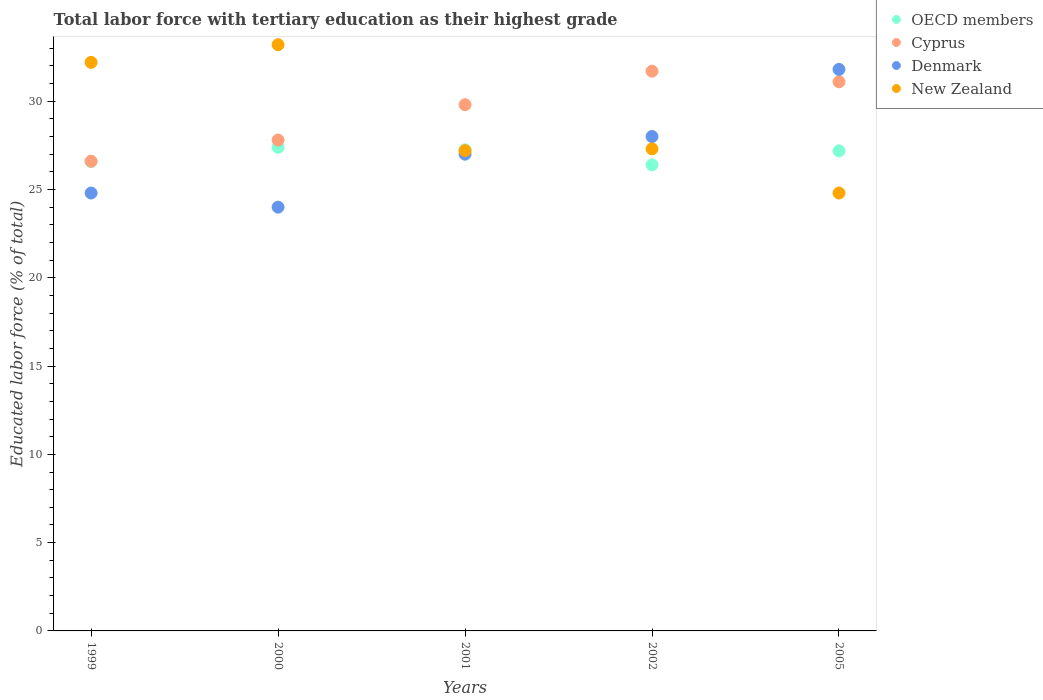How many different coloured dotlines are there?
Make the answer very short. 4. Is the number of dotlines equal to the number of legend labels?
Make the answer very short. Yes. What is the percentage of male labor force with tertiary education in Cyprus in 2005?
Provide a short and direct response. 31.1. Across all years, what is the maximum percentage of male labor force with tertiary education in Denmark?
Provide a succinct answer. 31.8. Across all years, what is the minimum percentage of male labor force with tertiary education in OECD members?
Offer a terse response. 26.4. In which year was the percentage of male labor force with tertiary education in Denmark minimum?
Your answer should be very brief. 2000. What is the total percentage of male labor force with tertiary education in Cyprus in the graph?
Offer a very short reply. 147. What is the difference between the percentage of male labor force with tertiary education in Denmark in 1999 and that in 2002?
Offer a terse response. -3.2. What is the average percentage of male labor force with tertiary education in OECD members per year?
Ensure brevity in your answer.  26.96. In the year 2001, what is the difference between the percentage of male labor force with tertiary education in Denmark and percentage of male labor force with tertiary education in Cyprus?
Your answer should be very brief. -2.8. What is the ratio of the percentage of male labor force with tertiary education in Cyprus in 2000 to that in 2002?
Make the answer very short. 0.88. What is the difference between the highest and the second highest percentage of male labor force with tertiary education in Cyprus?
Offer a terse response. 0.6. What is the difference between the highest and the lowest percentage of male labor force with tertiary education in Cyprus?
Keep it short and to the point. 5.1. In how many years, is the percentage of male labor force with tertiary education in Denmark greater than the average percentage of male labor force with tertiary education in Denmark taken over all years?
Keep it short and to the point. 2. Is the sum of the percentage of male labor force with tertiary education in OECD members in 1999 and 2001 greater than the maximum percentage of male labor force with tertiary education in Cyprus across all years?
Give a very brief answer. Yes. Is it the case that in every year, the sum of the percentage of male labor force with tertiary education in New Zealand and percentage of male labor force with tertiary education in Cyprus  is greater than the percentage of male labor force with tertiary education in OECD members?
Provide a succinct answer. Yes. Does the percentage of male labor force with tertiary education in OECD members monotonically increase over the years?
Your answer should be compact. No. Is the percentage of male labor force with tertiary education in Cyprus strictly greater than the percentage of male labor force with tertiary education in New Zealand over the years?
Your answer should be compact. No. Is the percentage of male labor force with tertiary education in Cyprus strictly less than the percentage of male labor force with tertiary education in OECD members over the years?
Give a very brief answer. No. How many dotlines are there?
Ensure brevity in your answer.  4. What is the difference between two consecutive major ticks on the Y-axis?
Provide a succinct answer. 5. Are the values on the major ticks of Y-axis written in scientific E-notation?
Your response must be concise. No. Does the graph contain grids?
Give a very brief answer. No. Where does the legend appear in the graph?
Your answer should be very brief. Top right. How many legend labels are there?
Provide a short and direct response. 4. How are the legend labels stacked?
Offer a very short reply. Vertical. What is the title of the graph?
Offer a terse response. Total labor force with tertiary education as their highest grade. What is the label or title of the X-axis?
Provide a short and direct response. Years. What is the label or title of the Y-axis?
Offer a terse response. Educated labor force (% of total). What is the Educated labor force (% of total) of OECD members in 1999?
Your answer should be compact. 26.58. What is the Educated labor force (% of total) in Cyprus in 1999?
Your response must be concise. 26.6. What is the Educated labor force (% of total) in Denmark in 1999?
Ensure brevity in your answer.  24.8. What is the Educated labor force (% of total) in New Zealand in 1999?
Keep it short and to the point. 32.2. What is the Educated labor force (% of total) in OECD members in 2000?
Make the answer very short. 27.39. What is the Educated labor force (% of total) in Cyprus in 2000?
Make the answer very short. 27.8. What is the Educated labor force (% of total) in New Zealand in 2000?
Provide a short and direct response. 33.2. What is the Educated labor force (% of total) of OECD members in 2001?
Keep it short and to the point. 27.25. What is the Educated labor force (% of total) of Cyprus in 2001?
Provide a succinct answer. 29.8. What is the Educated labor force (% of total) in New Zealand in 2001?
Ensure brevity in your answer.  27.2. What is the Educated labor force (% of total) of OECD members in 2002?
Make the answer very short. 26.4. What is the Educated labor force (% of total) of Cyprus in 2002?
Offer a very short reply. 31.7. What is the Educated labor force (% of total) of New Zealand in 2002?
Offer a terse response. 27.3. What is the Educated labor force (% of total) of OECD members in 2005?
Your response must be concise. 27.19. What is the Educated labor force (% of total) in Cyprus in 2005?
Your answer should be compact. 31.1. What is the Educated labor force (% of total) of Denmark in 2005?
Keep it short and to the point. 31.8. What is the Educated labor force (% of total) in New Zealand in 2005?
Make the answer very short. 24.8. Across all years, what is the maximum Educated labor force (% of total) in OECD members?
Give a very brief answer. 27.39. Across all years, what is the maximum Educated labor force (% of total) in Cyprus?
Make the answer very short. 31.7. Across all years, what is the maximum Educated labor force (% of total) in Denmark?
Provide a succinct answer. 31.8. Across all years, what is the maximum Educated labor force (% of total) of New Zealand?
Your response must be concise. 33.2. Across all years, what is the minimum Educated labor force (% of total) of OECD members?
Your answer should be very brief. 26.4. Across all years, what is the minimum Educated labor force (% of total) of Cyprus?
Offer a terse response. 26.6. Across all years, what is the minimum Educated labor force (% of total) in New Zealand?
Your answer should be very brief. 24.8. What is the total Educated labor force (% of total) in OECD members in the graph?
Offer a very short reply. 134.8. What is the total Educated labor force (% of total) of Cyprus in the graph?
Ensure brevity in your answer.  147. What is the total Educated labor force (% of total) of Denmark in the graph?
Make the answer very short. 135.6. What is the total Educated labor force (% of total) of New Zealand in the graph?
Ensure brevity in your answer.  144.7. What is the difference between the Educated labor force (% of total) in OECD members in 1999 and that in 2000?
Your response must be concise. -0.81. What is the difference between the Educated labor force (% of total) in Cyprus in 1999 and that in 2000?
Make the answer very short. -1.2. What is the difference between the Educated labor force (% of total) of OECD members in 1999 and that in 2001?
Give a very brief answer. -0.66. What is the difference between the Educated labor force (% of total) in Denmark in 1999 and that in 2001?
Your response must be concise. -2.2. What is the difference between the Educated labor force (% of total) of New Zealand in 1999 and that in 2001?
Provide a succinct answer. 5. What is the difference between the Educated labor force (% of total) of OECD members in 1999 and that in 2002?
Offer a very short reply. 0.19. What is the difference between the Educated labor force (% of total) of New Zealand in 1999 and that in 2002?
Keep it short and to the point. 4.9. What is the difference between the Educated labor force (% of total) of OECD members in 1999 and that in 2005?
Your response must be concise. -0.61. What is the difference between the Educated labor force (% of total) of New Zealand in 1999 and that in 2005?
Keep it short and to the point. 7.4. What is the difference between the Educated labor force (% of total) of OECD members in 2000 and that in 2001?
Your response must be concise. 0.14. What is the difference between the Educated labor force (% of total) in Denmark in 2000 and that in 2001?
Your response must be concise. -3. What is the difference between the Educated labor force (% of total) of New Zealand in 2000 and that in 2001?
Make the answer very short. 6. What is the difference between the Educated labor force (% of total) of Denmark in 2000 and that in 2002?
Your answer should be very brief. -4. What is the difference between the Educated labor force (% of total) of New Zealand in 2000 and that in 2002?
Offer a terse response. 5.9. What is the difference between the Educated labor force (% of total) of OECD members in 2000 and that in 2005?
Offer a very short reply. 0.2. What is the difference between the Educated labor force (% of total) of Cyprus in 2000 and that in 2005?
Your response must be concise. -3.3. What is the difference between the Educated labor force (% of total) of OECD members in 2001 and that in 2002?
Offer a very short reply. 0.85. What is the difference between the Educated labor force (% of total) of Denmark in 2001 and that in 2002?
Give a very brief answer. -1. What is the difference between the Educated labor force (% of total) in OECD members in 2001 and that in 2005?
Provide a short and direct response. 0.06. What is the difference between the Educated labor force (% of total) of Cyprus in 2001 and that in 2005?
Ensure brevity in your answer.  -1.3. What is the difference between the Educated labor force (% of total) in OECD members in 2002 and that in 2005?
Ensure brevity in your answer.  -0.79. What is the difference between the Educated labor force (% of total) in Cyprus in 2002 and that in 2005?
Ensure brevity in your answer.  0.6. What is the difference between the Educated labor force (% of total) of Denmark in 2002 and that in 2005?
Keep it short and to the point. -3.8. What is the difference between the Educated labor force (% of total) in New Zealand in 2002 and that in 2005?
Offer a terse response. 2.5. What is the difference between the Educated labor force (% of total) of OECD members in 1999 and the Educated labor force (% of total) of Cyprus in 2000?
Ensure brevity in your answer.  -1.22. What is the difference between the Educated labor force (% of total) in OECD members in 1999 and the Educated labor force (% of total) in Denmark in 2000?
Provide a succinct answer. 2.58. What is the difference between the Educated labor force (% of total) of OECD members in 1999 and the Educated labor force (% of total) of New Zealand in 2000?
Your response must be concise. -6.62. What is the difference between the Educated labor force (% of total) of Cyprus in 1999 and the Educated labor force (% of total) of Denmark in 2000?
Your answer should be compact. 2.6. What is the difference between the Educated labor force (% of total) of Denmark in 1999 and the Educated labor force (% of total) of New Zealand in 2000?
Ensure brevity in your answer.  -8.4. What is the difference between the Educated labor force (% of total) in OECD members in 1999 and the Educated labor force (% of total) in Cyprus in 2001?
Offer a terse response. -3.22. What is the difference between the Educated labor force (% of total) in OECD members in 1999 and the Educated labor force (% of total) in Denmark in 2001?
Provide a succinct answer. -0.42. What is the difference between the Educated labor force (% of total) in OECD members in 1999 and the Educated labor force (% of total) in New Zealand in 2001?
Offer a very short reply. -0.62. What is the difference between the Educated labor force (% of total) of Cyprus in 1999 and the Educated labor force (% of total) of New Zealand in 2001?
Your answer should be very brief. -0.6. What is the difference between the Educated labor force (% of total) in Denmark in 1999 and the Educated labor force (% of total) in New Zealand in 2001?
Make the answer very short. -2.4. What is the difference between the Educated labor force (% of total) in OECD members in 1999 and the Educated labor force (% of total) in Cyprus in 2002?
Keep it short and to the point. -5.12. What is the difference between the Educated labor force (% of total) in OECD members in 1999 and the Educated labor force (% of total) in Denmark in 2002?
Your response must be concise. -1.42. What is the difference between the Educated labor force (% of total) of OECD members in 1999 and the Educated labor force (% of total) of New Zealand in 2002?
Provide a short and direct response. -0.72. What is the difference between the Educated labor force (% of total) of Cyprus in 1999 and the Educated labor force (% of total) of Denmark in 2002?
Your answer should be compact. -1.4. What is the difference between the Educated labor force (% of total) in Cyprus in 1999 and the Educated labor force (% of total) in New Zealand in 2002?
Offer a very short reply. -0.7. What is the difference between the Educated labor force (% of total) of Denmark in 1999 and the Educated labor force (% of total) of New Zealand in 2002?
Your answer should be compact. -2.5. What is the difference between the Educated labor force (% of total) in OECD members in 1999 and the Educated labor force (% of total) in Cyprus in 2005?
Ensure brevity in your answer.  -4.52. What is the difference between the Educated labor force (% of total) of OECD members in 1999 and the Educated labor force (% of total) of Denmark in 2005?
Offer a very short reply. -5.22. What is the difference between the Educated labor force (% of total) of OECD members in 1999 and the Educated labor force (% of total) of New Zealand in 2005?
Your answer should be compact. 1.78. What is the difference between the Educated labor force (% of total) of Cyprus in 1999 and the Educated labor force (% of total) of New Zealand in 2005?
Your answer should be compact. 1.8. What is the difference between the Educated labor force (% of total) of OECD members in 2000 and the Educated labor force (% of total) of Cyprus in 2001?
Ensure brevity in your answer.  -2.41. What is the difference between the Educated labor force (% of total) of OECD members in 2000 and the Educated labor force (% of total) of Denmark in 2001?
Give a very brief answer. 0.39. What is the difference between the Educated labor force (% of total) of OECD members in 2000 and the Educated labor force (% of total) of New Zealand in 2001?
Keep it short and to the point. 0.19. What is the difference between the Educated labor force (% of total) in Cyprus in 2000 and the Educated labor force (% of total) in Denmark in 2001?
Provide a succinct answer. 0.8. What is the difference between the Educated labor force (% of total) in Denmark in 2000 and the Educated labor force (% of total) in New Zealand in 2001?
Offer a very short reply. -3.2. What is the difference between the Educated labor force (% of total) of OECD members in 2000 and the Educated labor force (% of total) of Cyprus in 2002?
Provide a succinct answer. -4.31. What is the difference between the Educated labor force (% of total) of OECD members in 2000 and the Educated labor force (% of total) of Denmark in 2002?
Give a very brief answer. -0.61. What is the difference between the Educated labor force (% of total) of OECD members in 2000 and the Educated labor force (% of total) of New Zealand in 2002?
Ensure brevity in your answer.  0.09. What is the difference between the Educated labor force (% of total) of Cyprus in 2000 and the Educated labor force (% of total) of Denmark in 2002?
Offer a very short reply. -0.2. What is the difference between the Educated labor force (% of total) of Denmark in 2000 and the Educated labor force (% of total) of New Zealand in 2002?
Your answer should be very brief. -3.3. What is the difference between the Educated labor force (% of total) of OECD members in 2000 and the Educated labor force (% of total) of Cyprus in 2005?
Keep it short and to the point. -3.71. What is the difference between the Educated labor force (% of total) of OECD members in 2000 and the Educated labor force (% of total) of Denmark in 2005?
Provide a short and direct response. -4.41. What is the difference between the Educated labor force (% of total) of OECD members in 2000 and the Educated labor force (% of total) of New Zealand in 2005?
Give a very brief answer. 2.59. What is the difference between the Educated labor force (% of total) in Cyprus in 2000 and the Educated labor force (% of total) in Denmark in 2005?
Your response must be concise. -4. What is the difference between the Educated labor force (% of total) of OECD members in 2001 and the Educated labor force (% of total) of Cyprus in 2002?
Ensure brevity in your answer.  -4.45. What is the difference between the Educated labor force (% of total) of OECD members in 2001 and the Educated labor force (% of total) of Denmark in 2002?
Your response must be concise. -0.75. What is the difference between the Educated labor force (% of total) of OECD members in 2001 and the Educated labor force (% of total) of New Zealand in 2002?
Provide a short and direct response. -0.05. What is the difference between the Educated labor force (% of total) of Cyprus in 2001 and the Educated labor force (% of total) of New Zealand in 2002?
Make the answer very short. 2.5. What is the difference between the Educated labor force (% of total) in Denmark in 2001 and the Educated labor force (% of total) in New Zealand in 2002?
Ensure brevity in your answer.  -0.3. What is the difference between the Educated labor force (% of total) of OECD members in 2001 and the Educated labor force (% of total) of Cyprus in 2005?
Provide a short and direct response. -3.85. What is the difference between the Educated labor force (% of total) in OECD members in 2001 and the Educated labor force (% of total) in Denmark in 2005?
Provide a succinct answer. -4.55. What is the difference between the Educated labor force (% of total) in OECD members in 2001 and the Educated labor force (% of total) in New Zealand in 2005?
Provide a succinct answer. 2.45. What is the difference between the Educated labor force (% of total) in Cyprus in 2001 and the Educated labor force (% of total) in New Zealand in 2005?
Your answer should be very brief. 5. What is the difference between the Educated labor force (% of total) of OECD members in 2002 and the Educated labor force (% of total) of Cyprus in 2005?
Your answer should be compact. -4.7. What is the difference between the Educated labor force (% of total) in OECD members in 2002 and the Educated labor force (% of total) in Denmark in 2005?
Keep it short and to the point. -5.4. What is the difference between the Educated labor force (% of total) in OECD members in 2002 and the Educated labor force (% of total) in New Zealand in 2005?
Keep it short and to the point. 1.6. What is the difference between the Educated labor force (% of total) of Cyprus in 2002 and the Educated labor force (% of total) of Denmark in 2005?
Your response must be concise. -0.1. What is the difference between the Educated labor force (% of total) in Cyprus in 2002 and the Educated labor force (% of total) in New Zealand in 2005?
Your answer should be compact. 6.9. What is the average Educated labor force (% of total) in OECD members per year?
Your answer should be compact. 26.96. What is the average Educated labor force (% of total) of Cyprus per year?
Ensure brevity in your answer.  29.4. What is the average Educated labor force (% of total) of Denmark per year?
Your answer should be very brief. 27.12. What is the average Educated labor force (% of total) of New Zealand per year?
Make the answer very short. 28.94. In the year 1999, what is the difference between the Educated labor force (% of total) in OECD members and Educated labor force (% of total) in Cyprus?
Keep it short and to the point. -0.02. In the year 1999, what is the difference between the Educated labor force (% of total) of OECD members and Educated labor force (% of total) of Denmark?
Give a very brief answer. 1.78. In the year 1999, what is the difference between the Educated labor force (% of total) in OECD members and Educated labor force (% of total) in New Zealand?
Ensure brevity in your answer.  -5.62. In the year 1999, what is the difference between the Educated labor force (% of total) of Cyprus and Educated labor force (% of total) of New Zealand?
Give a very brief answer. -5.6. In the year 2000, what is the difference between the Educated labor force (% of total) of OECD members and Educated labor force (% of total) of Cyprus?
Make the answer very short. -0.41. In the year 2000, what is the difference between the Educated labor force (% of total) of OECD members and Educated labor force (% of total) of Denmark?
Your answer should be very brief. 3.39. In the year 2000, what is the difference between the Educated labor force (% of total) of OECD members and Educated labor force (% of total) of New Zealand?
Your answer should be very brief. -5.81. In the year 2000, what is the difference between the Educated labor force (% of total) in Denmark and Educated labor force (% of total) in New Zealand?
Give a very brief answer. -9.2. In the year 2001, what is the difference between the Educated labor force (% of total) of OECD members and Educated labor force (% of total) of Cyprus?
Your answer should be very brief. -2.55. In the year 2001, what is the difference between the Educated labor force (% of total) of OECD members and Educated labor force (% of total) of Denmark?
Your answer should be compact. 0.25. In the year 2001, what is the difference between the Educated labor force (% of total) in OECD members and Educated labor force (% of total) in New Zealand?
Provide a short and direct response. 0.05. In the year 2001, what is the difference between the Educated labor force (% of total) of Cyprus and Educated labor force (% of total) of New Zealand?
Your response must be concise. 2.6. In the year 2002, what is the difference between the Educated labor force (% of total) of OECD members and Educated labor force (% of total) of Cyprus?
Offer a very short reply. -5.3. In the year 2002, what is the difference between the Educated labor force (% of total) of OECD members and Educated labor force (% of total) of Denmark?
Provide a succinct answer. -1.6. In the year 2002, what is the difference between the Educated labor force (% of total) of OECD members and Educated labor force (% of total) of New Zealand?
Offer a terse response. -0.9. In the year 2002, what is the difference between the Educated labor force (% of total) of Cyprus and Educated labor force (% of total) of Denmark?
Your answer should be compact. 3.7. In the year 2005, what is the difference between the Educated labor force (% of total) in OECD members and Educated labor force (% of total) in Cyprus?
Offer a terse response. -3.91. In the year 2005, what is the difference between the Educated labor force (% of total) of OECD members and Educated labor force (% of total) of Denmark?
Ensure brevity in your answer.  -4.61. In the year 2005, what is the difference between the Educated labor force (% of total) in OECD members and Educated labor force (% of total) in New Zealand?
Your response must be concise. 2.39. In the year 2005, what is the difference between the Educated labor force (% of total) in Cyprus and Educated labor force (% of total) in Denmark?
Keep it short and to the point. -0.7. In the year 2005, what is the difference between the Educated labor force (% of total) in Cyprus and Educated labor force (% of total) in New Zealand?
Offer a terse response. 6.3. In the year 2005, what is the difference between the Educated labor force (% of total) in Denmark and Educated labor force (% of total) in New Zealand?
Provide a short and direct response. 7. What is the ratio of the Educated labor force (% of total) of OECD members in 1999 to that in 2000?
Provide a short and direct response. 0.97. What is the ratio of the Educated labor force (% of total) of Cyprus in 1999 to that in 2000?
Ensure brevity in your answer.  0.96. What is the ratio of the Educated labor force (% of total) in Denmark in 1999 to that in 2000?
Keep it short and to the point. 1.03. What is the ratio of the Educated labor force (% of total) of New Zealand in 1999 to that in 2000?
Your answer should be very brief. 0.97. What is the ratio of the Educated labor force (% of total) in OECD members in 1999 to that in 2001?
Provide a succinct answer. 0.98. What is the ratio of the Educated labor force (% of total) in Cyprus in 1999 to that in 2001?
Ensure brevity in your answer.  0.89. What is the ratio of the Educated labor force (% of total) in Denmark in 1999 to that in 2001?
Your response must be concise. 0.92. What is the ratio of the Educated labor force (% of total) of New Zealand in 1999 to that in 2001?
Make the answer very short. 1.18. What is the ratio of the Educated labor force (% of total) of Cyprus in 1999 to that in 2002?
Provide a succinct answer. 0.84. What is the ratio of the Educated labor force (% of total) of Denmark in 1999 to that in 2002?
Provide a short and direct response. 0.89. What is the ratio of the Educated labor force (% of total) of New Zealand in 1999 to that in 2002?
Your answer should be compact. 1.18. What is the ratio of the Educated labor force (% of total) in OECD members in 1999 to that in 2005?
Ensure brevity in your answer.  0.98. What is the ratio of the Educated labor force (% of total) of Cyprus in 1999 to that in 2005?
Your response must be concise. 0.86. What is the ratio of the Educated labor force (% of total) in Denmark in 1999 to that in 2005?
Your answer should be very brief. 0.78. What is the ratio of the Educated labor force (% of total) of New Zealand in 1999 to that in 2005?
Offer a terse response. 1.3. What is the ratio of the Educated labor force (% of total) in Cyprus in 2000 to that in 2001?
Your response must be concise. 0.93. What is the ratio of the Educated labor force (% of total) in Denmark in 2000 to that in 2001?
Give a very brief answer. 0.89. What is the ratio of the Educated labor force (% of total) in New Zealand in 2000 to that in 2001?
Provide a short and direct response. 1.22. What is the ratio of the Educated labor force (% of total) of OECD members in 2000 to that in 2002?
Your answer should be compact. 1.04. What is the ratio of the Educated labor force (% of total) in Cyprus in 2000 to that in 2002?
Make the answer very short. 0.88. What is the ratio of the Educated labor force (% of total) of Denmark in 2000 to that in 2002?
Ensure brevity in your answer.  0.86. What is the ratio of the Educated labor force (% of total) of New Zealand in 2000 to that in 2002?
Provide a short and direct response. 1.22. What is the ratio of the Educated labor force (% of total) of OECD members in 2000 to that in 2005?
Offer a very short reply. 1.01. What is the ratio of the Educated labor force (% of total) in Cyprus in 2000 to that in 2005?
Keep it short and to the point. 0.89. What is the ratio of the Educated labor force (% of total) of Denmark in 2000 to that in 2005?
Your answer should be compact. 0.75. What is the ratio of the Educated labor force (% of total) in New Zealand in 2000 to that in 2005?
Offer a very short reply. 1.34. What is the ratio of the Educated labor force (% of total) in OECD members in 2001 to that in 2002?
Keep it short and to the point. 1.03. What is the ratio of the Educated labor force (% of total) in Cyprus in 2001 to that in 2002?
Your answer should be compact. 0.94. What is the ratio of the Educated labor force (% of total) of Denmark in 2001 to that in 2002?
Your response must be concise. 0.96. What is the ratio of the Educated labor force (% of total) of Cyprus in 2001 to that in 2005?
Give a very brief answer. 0.96. What is the ratio of the Educated labor force (% of total) of Denmark in 2001 to that in 2005?
Provide a succinct answer. 0.85. What is the ratio of the Educated labor force (% of total) in New Zealand in 2001 to that in 2005?
Offer a terse response. 1.1. What is the ratio of the Educated labor force (% of total) in OECD members in 2002 to that in 2005?
Make the answer very short. 0.97. What is the ratio of the Educated labor force (% of total) in Cyprus in 2002 to that in 2005?
Make the answer very short. 1.02. What is the ratio of the Educated labor force (% of total) of Denmark in 2002 to that in 2005?
Provide a short and direct response. 0.88. What is the ratio of the Educated labor force (% of total) in New Zealand in 2002 to that in 2005?
Your answer should be very brief. 1.1. What is the difference between the highest and the second highest Educated labor force (% of total) in OECD members?
Provide a short and direct response. 0.14. What is the difference between the highest and the second highest Educated labor force (% of total) of Denmark?
Provide a succinct answer. 3.8. What is the difference between the highest and the lowest Educated labor force (% of total) in OECD members?
Make the answer very short. 0.99. 